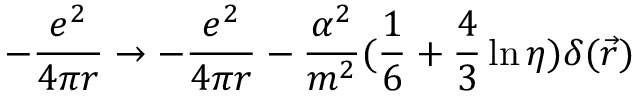<formula> <loc_0><loc_0><loc_500><loc_500>- \frac { e ^ { 2 } } { 4 \pi r } \rightarrow - \frac { e ^ { 2 } } { 4 \pi r } - \frac { \alpha ^ { 2 } } { m ^ { 2 } } ( \frac { 1 } { 6 } + \frac { 4 } { 3 } \ln \eta ) \delta ( \vec { r } )</formula> 